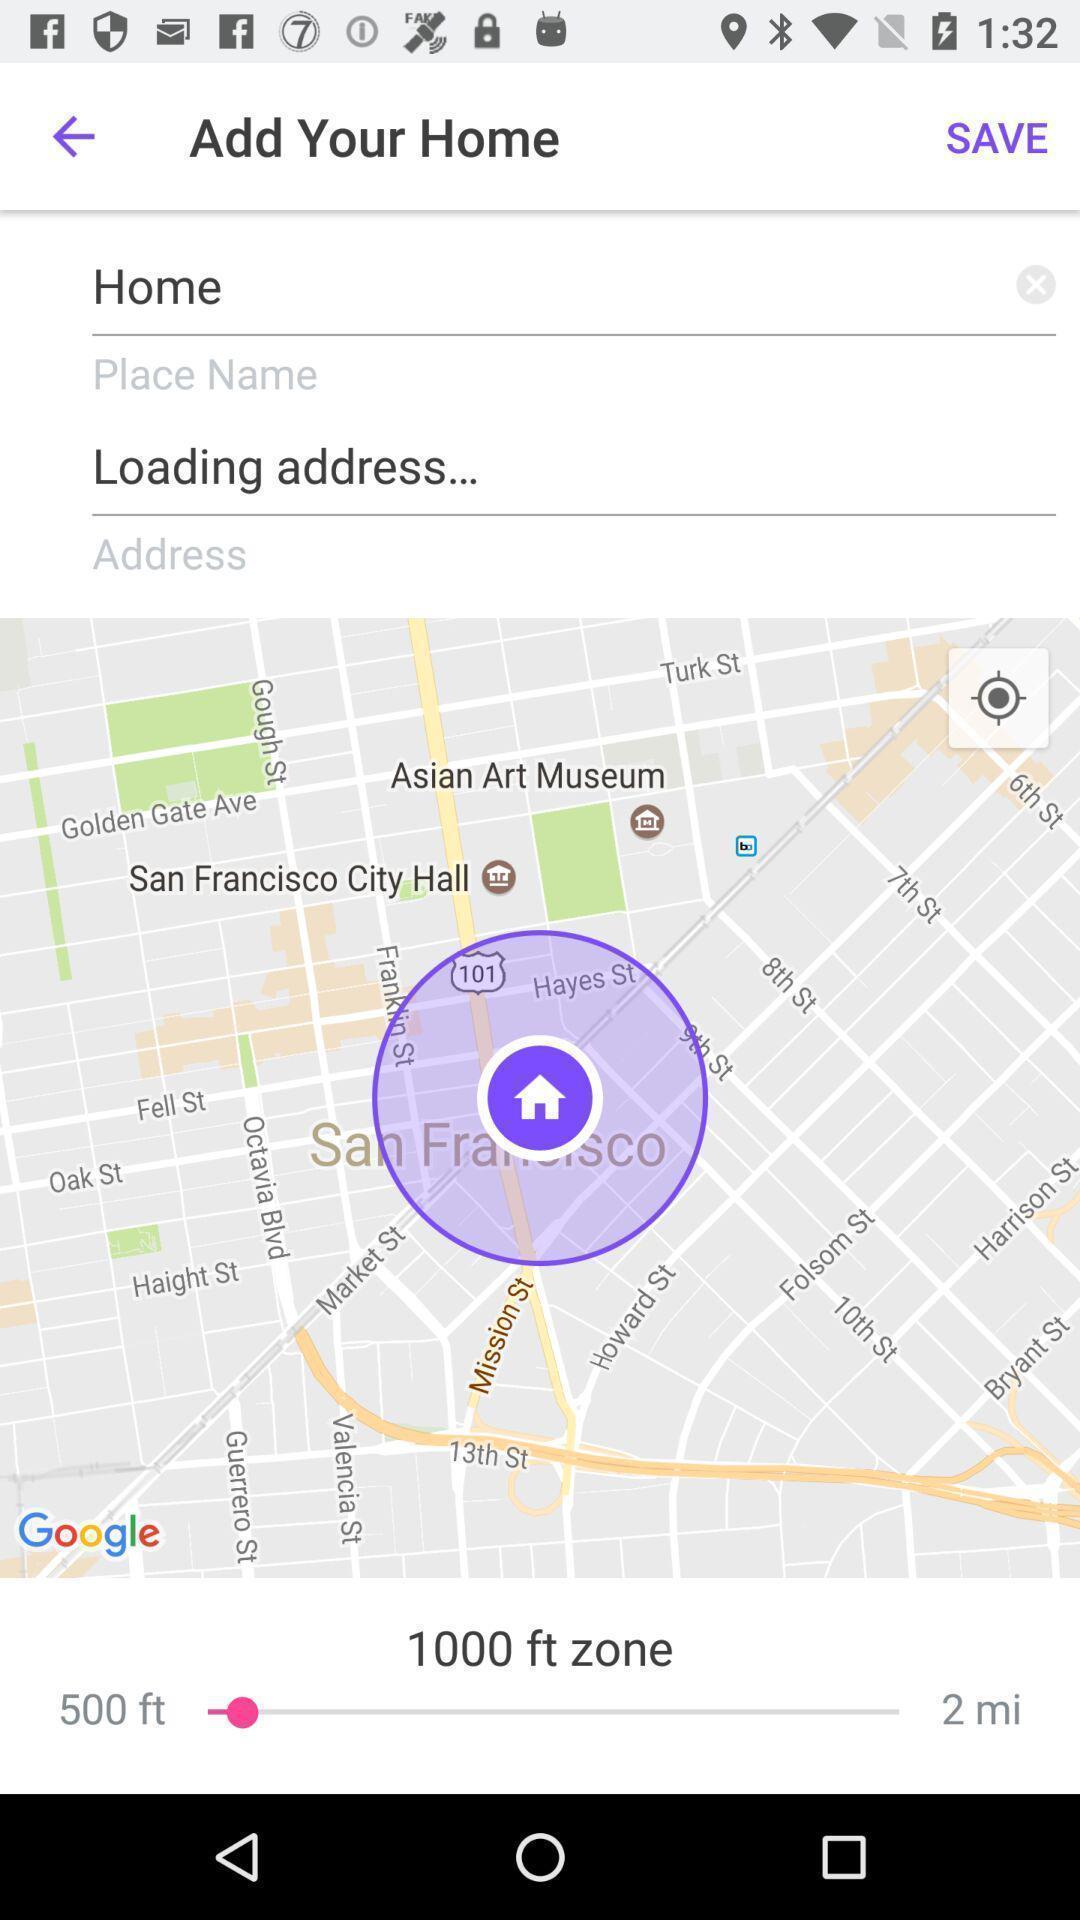Describe the visual elements of this screenshot. Screen showing address editing page with map. 